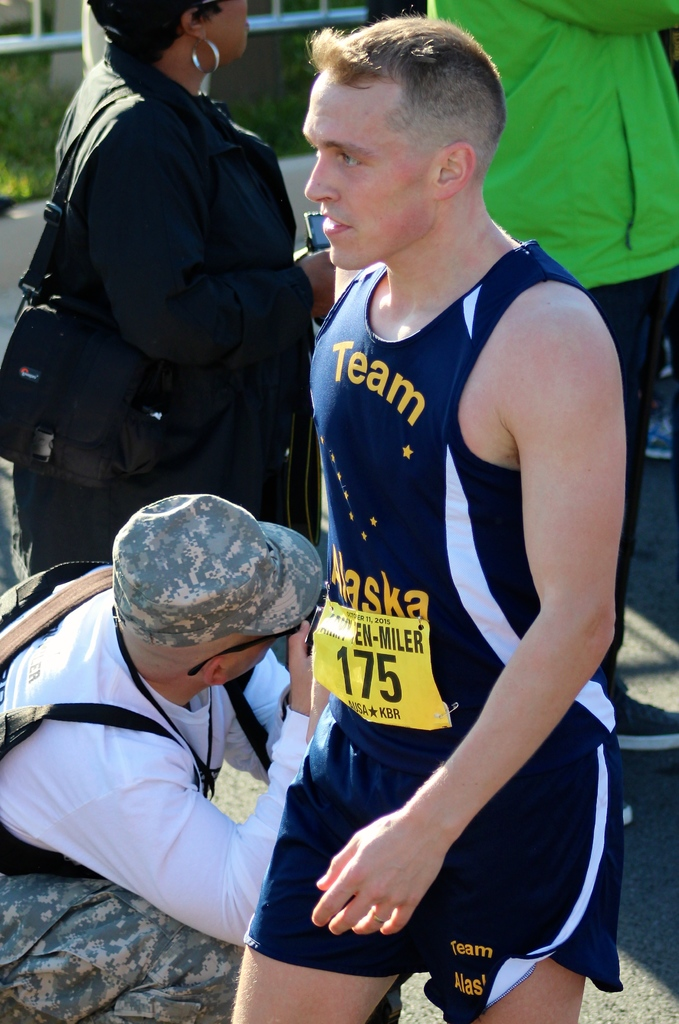Describe the setting and activity happening around the man in the image. The man is outdoors during a competitive running event, receiving assistance from a medic, which suggests he might be experiencing physical distress or injury in a high-stakes environment. What does his facial expression convey? His expression appears concentrated and fatigued, indicative of the intense exertion and determination often seen in athletes during challenging moments of a race. 